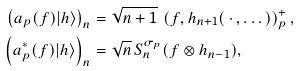Convert formula to latex. <formula><loc_0><loc_0><loc_500><loc_500>\left ( a _ { p } ( f ) | h \rangle \right ) _ { n } & = \sqrt { n + 1 } \, \left ( f , h _ { n + 1 } ( \, \cdot \, , \dots ) \right ) ^ { + } _ { p } , \\ \left ( a _ { p } ^ { \ast } ( f ) | h \rangle \right ) _ { n } & = \sqrt { n } \, S _ { n } ^ { \sigma _ { p } } ( f \otimes h _ { n - 1 } ) ,</formula> 